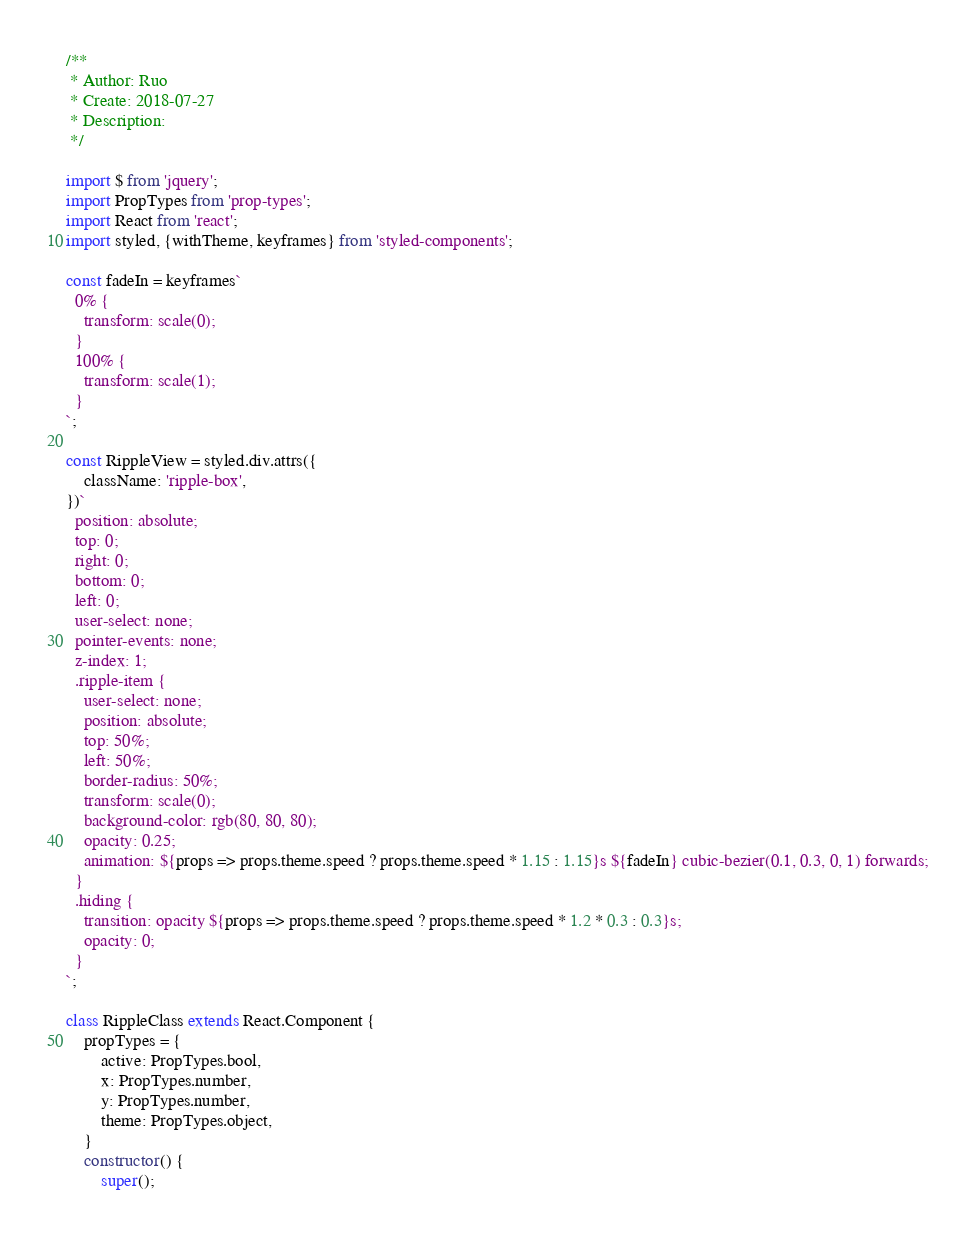<code> <loc_0><loc_0><loc_500><loc_500><_JavaScript_>/**
 * Author: Ruo
 * Create: 2018-07-27
 * Description:
 */

import $ from 'jquery';
import PropTypes from 'prop-types';
import React from 'react';
import styled, {withTheme, keyframes} from 'styled-components';

const fadeIn = keyframes`
  0% {
    transform: scale(0);
  }
  100% {
    transform: scale(1);
  }
`;

const RippleView = styled.div.attrs({
    className: 'ripple-box',
})`
  position: absolute;
  top: 0;
  right: 0;
  bottom: 0;
  left: 0;
  user-select: none;
  pointer-events: none;
  z-index: 1;
  .ripple-item {
    user-select: none;
    position: absolute;
    top: 50%;
    left: 50%;
    border-radius: 50%;
    transform: scale(0);
    background-color: rgb(80, 80, 80);
    opacity: 0.25;
    animation: ${props => props.theme.speed ? props.theme.speed * 1.15 : 1.15}s ${fadeIn} cubic-bezier(0.1, 0.3, 0, 1) forwards;
  }
  .hiding {
    transition: opacity ${props => props.theme.speed ? props.theme.speed * 1.2 * 0.3 : 0.3}s;
    opacity: 0;
  }
`;

class RippleClass extends React.Component {
    propTypes = {
        active: PropTypes.bool,
        x: PropTypes.number,
        y: PropTypes.number,
        theme: PropTypes.object,
    }
    constructor() {
        super();</code> 